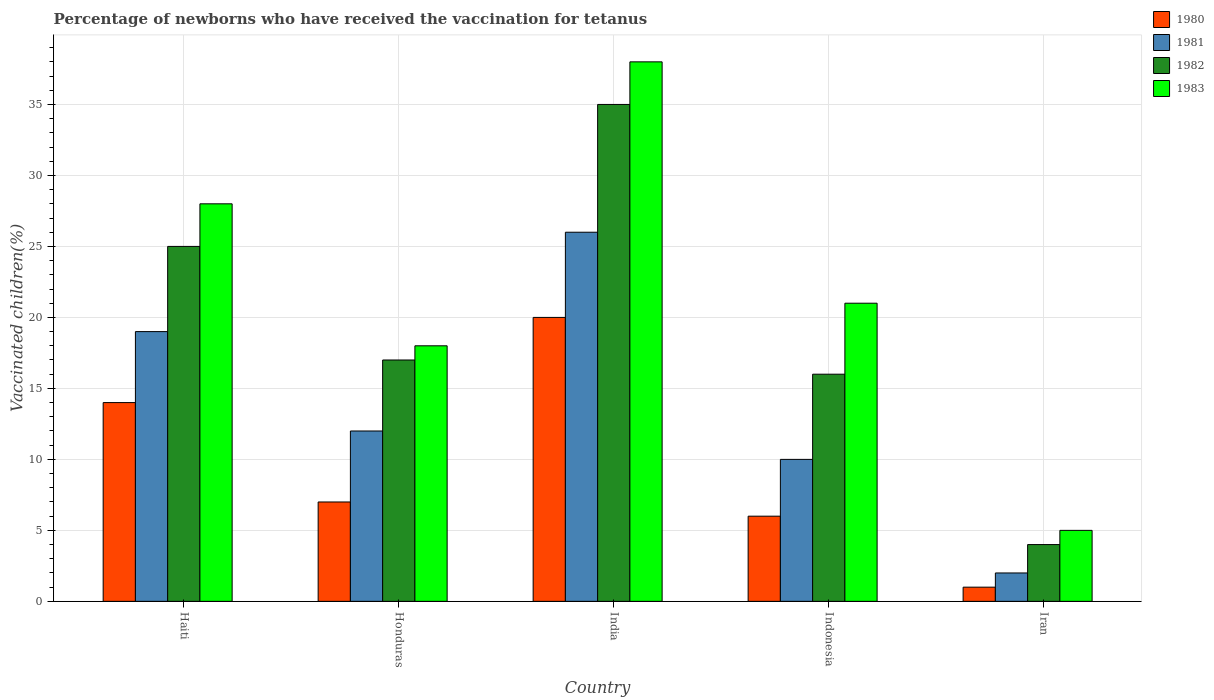Are the number of bars per tick equal to the number of legend labels?
Provide a short and direct response. Yes. Across all countries, what is the minimum percentage of vaccinated children in 1981?
Ensure brevity in your answer.  2. In which country was the percentage of vaccinated children in 1982 minimum?
Your answer should be very brief. Iran. What is the difference between the percentage of vaccinated children in 1981 in Haiti and that in Honduras?
Your response must be concise. 7. What is the difference between the percentage of vaccinated children in 1980 in India and the percentage of vaccinated children in 1981 in Honduras?
Provide a short and direct response. 8. What is the average percentage of vaccinated children in 1982 per country?
Your answer should be very brief. 19.4. What is the ratio of the percentage of vaccinated children in 1983 in India to that in Indonesia?
Your answer should be very brief. 1.81. Is the percentage of vaccinated children in 1981 in Honduras less than that in Indonesia?
Offer a terse response. No. What is the difference between the highest and the lowest percentage of vaccinated children in 1983?
Make the answer very short. 33. Is it the case that in every country, the sum of the percentage of vaccinated children in 1980 and percentage of vaccinated children in 1982 is greater than the sum of percentage of vaccinated children in 1983 and percentage of vaccinated children in 1981?
Offer a very short reply. No. Is it the case that in every country, the sum of the percentage of vaccinated children in 1982 and percentage of vaccinated children in 1980 is greater than the percentage of vaccinated children in 1981?
Your answer should be very brief. Yes. How many bars are there?
Offer a terse response. 20. Are the values on the major ticks of Y-axis written in scientific E-notation?
Provide a short and direct response. No. How many legend labels are there?
Give a very brief answer. 4. How are the legend labels stacked?
Offer a very short reply. Vertical. What is the title of the graph?
Provide a short and direct response. Percentage of newborns who have received the vaccination for tetanus. What is the label or title of the X-axis?
Keep it short and to the point. Country. What is the label or title of the Y-axis?
Make the answer very short. Vaccinated children(%). What is the Vaccinated children(%) of 1980 in Haiti?
Make the answer very short. 14. What is the Vaccinated children(%) in 1982 in Haiti?
Give a very brief answer. 25. What is the Vaccinated children(%) of 1983 in Haiti?
Provide a succinct answer. 28. What is the Vaccinated children(%) in 1982 in Honduras?
Provide a succinct answer. 17. What is the Vaccinated children(%) in 1981 in India?
Your answer should be compact. 26. What is the Vaccinated children(%) of 1980 in Indonesia?
Provide a succinct answer. 6. What is the Vaccinated children(%) in 1981 in Indonesia?
Provide a short and direct response. 10. What is the Vaccinated children(%) in 1983 in Iran?
Provide a succinct answer. 5. Across all countries, what is the maximum Vaccinated children(%) in 1981?
Your response must be concise. 26. Across all countries, what is the maximum Vaccinated children(%) in 1982?
Your answer should be very brief. 35. Across all countries, what is the maximum Vaccinated children(%) in 1983?
Make the answer very short. 38. Across all countries, what is the minimum Vaccinated children(%) in 1980?
Make the answer very short. 1. Across all countries, what is the minimum Vaccinated children(%) in 1981?
Provide a succinct answer. 2. What is the total Vaccinated children(%) of 1980 in the graph?
Provide a short and direct response. 48. What is the total Vaccinated children(%) of 1982 in the graph?
Keep it short and to the point. 97. What is the total Vaccinated children(%) of 1983 in the graph?
Provide a short and direct response. 110. What is the difference between the Vaccinated children(%) in 1980 in Haiti and that in Honduras?
Ensure brevity in your answer.  7. What is the difference between the Vaccinated children(%) in 1982 in Haiti and that in Honduras?
Your answer should be compact. 8. What is the difference between the Vaccinated children(%) in 1981 in Haiti and that in India?
Provide a succinct answer. -7. What is the difference between the Vaccinated children(%) of 1982 in Haiti and that in India?
Offer a very short reply. -10. What is the difference between the Vaccinated children(%) of 1981 in Haiti and that in Indonesia?
Provide a succinct answer. 9. What is the difference between the Vaccinated children(%) in 1982 in Haiti and that in Indonesia?
Your answer should be very brief. 9. What is the difference between the Vaccinated children(%) in 1980 in Haiti and that in Iran?
Your response must be concise. 13. What is the difference between the Vaccinated children(%) of 1981 in Haiti and that in Iran?
Your answer should be compact. 17. What is the difference between the Vaccinated children(%) in 1980 in Honduras and that in India?
Make the answer very short. -13. What is the difference between the Vaccinated children(%) of 1981 in Honduras and that in India?
Make the answer very short. -14. What is the difference between the Vaccinated children(%) in 1982 in Honduras and that in India?
Give a very brief answer. -18. What is the difference between the Vaccinated children(%) of 1980 in Honduras and that in Iran?
Your answer should be very brief. 6. What is the difference between the Vaccinated children(%) of 1980 in India and that in Indonesia?
Offer a terse response. 14. What is the difference between the Vaccinated children(%) of 1981 in India and that in Indonesia?
Ensure brevity in your answer.  16. What is the difference between the Vaccinated children(%) of 1983 in India and that in Indonesia?
Offer a very short reply. 17. What is the difference between the Vaccinated children(%) of 1982 in India and that in Iran?
Offer a very short reply. 31. What is the difference between the Vaccinated children(%) of 1983 in Indonesia and that in Iran?
Offer a very short reply. 16. What is the difference between the Vaccinated children(%) in 1980 in Haiti and the Vaccinated children(%) in 1981 in Honduras?
Make the answer very short. 2. What is the difference between the Vaccinated children(%) in 1980 in Haiti and the Vaccinated children(%) in 1982 in Honduras?
Offer a very short reply. -3. What is the difference between the Vaccinated children(%) in 1980 in Haiti and the Vaccinated children(%) in 1983 in Honduras?
Provide a short and direct response. -4. What is the difference between the Vaccinated children(%) of 1981 in Haiti and the Vaccinated children(%) of 1982 in Honduras?
Provide a short and direct response. 2. What is the difference between the Vaccinated children(%) of 1980 in Haiti and the Vaccinated children(%) of 1982 in India?
Provide a short and direct response. -21. What is the difference between the Vaccinated children(%) in 1982 in Haiti and the Vaccinated children(%) in 1983 in India?
Give a very brief answer. -13. What is the difference between the Vaccinated children(%) of 1980 in Haiti and the Vaccinated children(%) of 1982 in Indonesia?
Your answer should be very brief. -2. What is the difference between the Vaccinated children(%) in 1980 in Haiti and the Vaccinated children(%) in 1983 in Indonesia?
Provide a short and direct response. -7. What is the difference between the Vaccinated children(%) in 1981 in Haiti and the Vaccinated children(%) in 1983 in Indonesia?
Offer a terse response. -2. What is the difference between the Vaccinated children(%) of 1982 in Haiti and the Vaccinated children(%) of 1983 in Indonesia?
Provide a succinct answer. 4. What is the difference between the Vaccinated children(%) of 1980 in Haiti and the Vaccinated children(%) of 1981 in Iran?
Make the answer very short. 12. What is the difference between the Vaccinated children(%) in 1980 in Haiti and the Vaccinated children(%) in 1982 in Iran?
Ensure brevity in your answer.  10. What is the difference between the Vaccinated children(%) in 1981 in Haiti and the Vaccinated children(%) in 1982 in Iran?
Your response must be concise. 15. What is the difference between the Vaccinated children(%) of 1980 in Honduras and the Vaccinated children(%) of 1982 in India?
Your answer should be compact. -28. What is the difference between the Vaccinated children(%) of 1980 in Honduras and the Vaccinated children(%) of 1983 in India?
Make the answer very short. -31. What is the difference between the Vaccinated children(%) of 1981 in Honduras and the Vaccinated children(%) of 1982 in India?
Provide a succinct answer. -23. What is the difference between the Vaccinated children(%) in 1981 in Honduras and the Vaccinated children(%) in 1983 in India?
Make the answer very short. -26. What is the difference between the Vaccinated children(%) in 1980 in Honduras and the Vaccinated children(%) in 1981 in Indonesia?
Give a very brief answer. -3. What is the difference between the Vaccinated children(%) of 1981 in Honduras and the Vaccinated children(%) of 1983 in Indonesia?
Make the answer very short. -9. What is the difference between the Vaccinated children(%) in 1980 in Honduras and the Vaccinated children(%) in 1983 in Iran?
Offer a very short reply. 2. What is the difference between the Vaccinated children(%) in 1981 in Honduras and the Vaccinated children(%) in 1982 in Iran?
Your response must be concise. 8. What is the difference between the Vaccinated children(%) in 1981 in Honduras and the Vaccinated children(%) in 1983 in Iran?
Your answer should be compact. 7. What is the difference between the Vaccinated children(%) of 1980 in India and the Vaccinated children(%) of 1981 in Indonesia?
Your answer should be compact. 10. What is the difference between the Vaccinated children(%) of 1980 in India and the Vaccinated children(%) of 1982 in Indonesia?
Provide a succinct answer. 4. What is the difference between the Vaccinated children(%) of 1981 in India and the Vaccinated children(%) of 1982 in Indonesia?
Provide a succinct answer. 10. What is the difference between the Vaccinated children(%) in 1981 in India and the Vaccinated children(%) in 1983 in Indonesia?
Provide a succinct answer. 5. What is the difference between the Vaccinated children(%) in 1982 in India and the Vaccinated children(%) in 1983 in Indonesia?
Give a very brief answer. 14. What is the difference between the Vaccinated children(%) in 1980 in India and the Vaccinated children(%) in 1982 in Iran?
Ensure brevity in your answer.  16. What is the difference between the Vaccinated children(%) in 1980 in Indonesia and the Vaccinated children(%) in 1981 in Iran?
Give a very brief answer. 4. What is the difference between the Vaccinated children(%) in 1980 in Indonesia and the Vaccinated children(%) in 1983 in Iran?
Provide a short and direct response. 1. What is the difference between the Vaccinated children(%) of 1982 in Indonesia and the Vaccinated children(%) of 1983 in Iran?
Provide a succinct answer. 11. What is the average Vaccinated children(%) in 1981 per country?
Make the answer very short. 13.8. What is the average Vaccinated children(%) in 1982 per country?
Your response must be concise. 19.4. What is the difference between the Vaccinated children(%) in 1980 and Vaccinated children(%) in 1981 in Haiti?
Provide a succinct answer. -5. What is the difference between the Vaccinated children(%) of 1980 and Vaccinated children(%) of 1982 in Haiti?
Provide a succinct answer. -11. What is the difference between the Vaccinated children(%) of 1980 and Vaccinated children(%) of 1983 in Haiti?
Your response must be concise. -14. What is the difference between the Vaccinated children(%) of 1981 and Vaccinated children(%) of 1982 in Haiti?
Ensure brevity in your answer.  -6. What is the difference between the Vaccinated children(%) in 1980 and Vaccinated children(%) in 1981 in Honduras?
Give a very brief answer. -5. What is the difference between the Vaccinated children(%) in 1980 and Vaccinated children(%) in 1982 in Honduras?
Ensure brevity in your answer.  -10. What is the difference between the Vaccinated children(%) in 1981 and Vaccinated children(%) in 1982 in Honduras?
Give a very brief answer. -5. What is the difference between the Vaccinated children(%) in 1981 and Vaccinated children(%) in 1983 in Honduras?
Make the answer very short. -6. What is the difference between the Vaccinated children(%) of 1980 and Vaccinated children(%) of 1981 in India?
Provide a short and direct response. -6. What is the difference between the Vaccinated children(%) of 1981 and Vaccinated children(%) of 1982 in India?
Your response must be concise. -9. What is the difference between the Vaccinated children(%) of 1981 and Vaccinated children(%) of 1983 in Indonesia?
Keep it short and to the point. -11. What is the difference between the Vaccinated children(%) in 1982 and Vaccinated children(%) in 1983 in Indonesia?
Your answer should be compact. -5. What is the difference between the Vaccinated children(%) in 1980 and Vaccinated children(%) in 1981 in Iran?
Ensure brevity in your answer.  -1. What is the difference between the Vaccinated children(%) of 1981 and Vaccinated children(%) of 1982 in Iran?
Provide a short and direct response. -2. What is the difference between the Vaccinated children(%) in 1981 and Vaccinated children(%) in 1983 in Iran?
Your response must be concise. -3. What is the ratio of the Vaccinated children(%) in 1980 in Haiti to that in Honduras?
Keep it short and to the point. 2. What is the ratio of the Vaccinated children(%) in 1981 in Haiti to that in Honduras?
Your answer should be very brief. 1.58. What is the ratio of the Vaccinated children(%) of 1982 in Haiti to that in Honduras?
Ensure brevity in your answer.  1.47. What is the ratio of the Vaccinated children(%) in 1983 in Haiti to that in Honduras?
Ensure brevity in your answer.  1.56. What is the ratio of the Vaccinated children(%) of 1981 in Haiti to that in India?
Your answer should be very brief. 0.73. What is the ratio of the Vaccinated children(%) in 1983 in Haiti to that in India?
Your answer should be compact. 0.74. What is the ratio of the Vaccinated children(%) in 1980 in Haiti to that in Indonesia?
Give a very brief answer. 2.33. What is the ratio of the Vaccinated children(%) of 1982 in Haiti to that in Indonesia?
Provide a short and direct response. 1.56. What is the ratio of the Vaccinated children(%) of 1980 in Haiti to that in Iran?
Offer a terse response. 14. What is the ratio of the Vaccinated children(%) in 1982 in Haiti to that in Iran?
Your answer should be very brief. 6.25. What is the ratio of the Vaccinated children(%) in 1981 in Honduras to that in India?
Keep it short and to the point. 0.46. What is the ratio of the Vaccinated children(%) in 1982 in Honduras to that in India?
Your response must be concise. 0.49. What is the ratio of the Vaccinated children(%) in 1983 in Honduras to that in India?
Your answer should be very brief. 0.47. What is the ratio of the Vaccinated children(%) of 1980 in Honduras to that in Indonesia?
Offer a terse response. 1.17. What is the ratio of the Vaccinated children(%) in 1983 in Honduras to that in Indonesia?
Make the answer very short. 0.86. What is the ratio of the Vaccinated children(%) of 1982 in Honduras to that in Iran?
Your answer should be compact. 4.25. What is the ratio of the Vaccinated children(%) in 1981 in India to that in Indonesia?
Keep it short and to the point. 2.6. What is the ratio of the Vaccinated children(%) of 1982 in India to that in Indonesia?
Provide a succinct answer. 2.19. What is the ratio of the Vaccinated children(%) of 1983 in India to that in Indonesia?
Give a very brief answer. 1.81. What is the ratio of the Vaccinated children(%) of 1980 in India to that in Iran?
Keep it short and to the point. 20. What is the ratio of the Vaccinated children(%) in 1982 in India to that in Iran?
Provide a succinct answer. 8.75. What is the ratio of the Vaccinated children(%) of 1981 in Indonesia to that in Iran?
Provide a short and direct response. 5. What is the ratio of the Vaccinated children(%) of 1983 in Indonesia to that in Iran?
Provide a succinct answer. 4.2. What is the difference between the highest and the second highest Vaccinated children(%) of 1980?
Provide a succinct answer. 6. What is the difference between the highest and the second highest Vaccinated children(%) in 1981?
Your answer should be compact. 7. What is the difference between the highest and the second highest Vaccinated children(%) in 1983?
Your response must be concise. 10. What is the difference between the highest and the lowest Vaccinated children(%) of 1981?
Keep it short and to the point. 24. What is the difference between the highest and the lowest Vaccinated children(%) of 1982?
Provide a succinct answer. 31. 